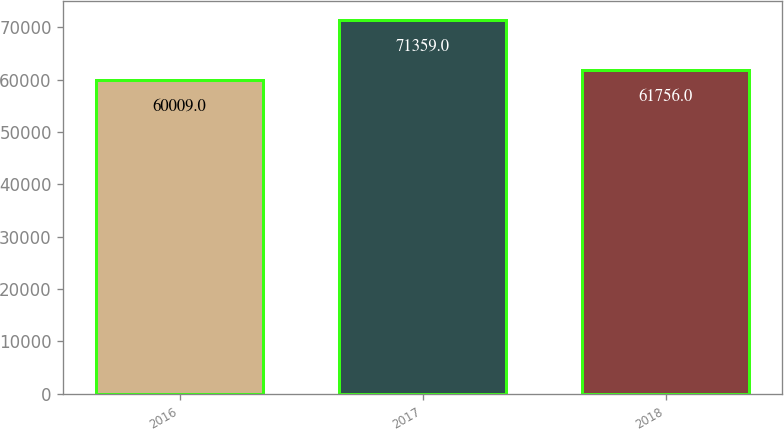Convert chart. <chart><loc_0><loc_0><loc_500><loc_500><bar_chart><fcel>2016<fcel>2017<fcel>2018<nl><fcel>60009<fcel>71359<fcel>61756<nl></chart> 